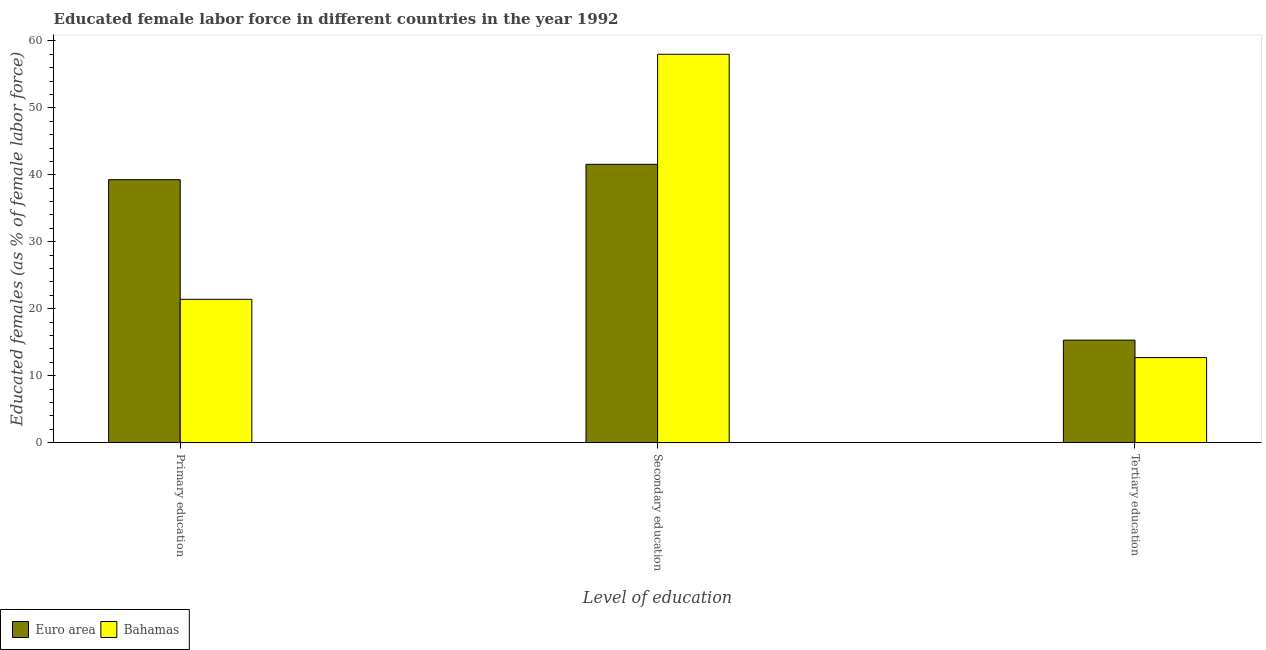How many different coloured bars are there?
Give a very brief answer. 2. Are the number of bars per tick equal to the number of legend labels?
Give a very brief answer. Yes. What is the percentage of female labor force who received primary education in Euro area?
Offer a very short reply. 39.27. Across all countries, what is the maximum percentage of female labor force who received secondary education?
Your response must be concise. 58. Across all countries, what is the minimum percentage of female labor force who received tertiary education?
Make the answer very short. 12.7. In which country was the percentage of female labor force who received secondary education maximum?
Provide a short and direct response. Bahamas. What is the total percentage of female labor force who received primary education in the graph?
Provide a succinct answer. 60.67. What is the difference between the percentage of female labor force who received primary education in Bahamas and that in Euro area?
Offer a very short reply. -17.87. What is the difference between the percentage of female labor force who received primary education in Bahamas and the percentage of female labor force who received tertiary education in Euro area?
Your response must be concise. 6.09. What is the average percentage of female labor force who received secondary education per country?
Ensure brevity in your answer.  49.78. What is the difference between the percentage of female labor force who received tertiary education and percentage of female labor force who received primary education in Euro area?
Your answer should be compact. -23.96. In how many countries, is the percentage of female labor force who received secondary education greater than 24 %?
Make the answer very short. 2. What is the ratio of the percentage of female labor force who received primary education in Bahamas to that in Euro area?
Make the answer very short. 0.54. Is the percentage of female labor force who received secondary education in Euro area less than that in Bahamas?
Ensure brevity in your answer.  Yes. Is the difference between the percentage of female labor force who received tertiary education in Euro area and Bahamas greater than the difference between the percentage of female labor force who received primary education in Euro area and Bahamas?
Your answer should be compact. No. What is the difference between the highest and the second highest percentage of female labor force who received tertiary education?
Keep it short and to the point. 2.61. What is the difference between the highest and the lowest percentage of female labor force who received secondary education?
Provide a short and direct response. 16.44. Is the sum of the percentage of female labor force who received primary education in Euro area and Bahamas greater than the maximum percentage of female labor force who received tertiary education across all countries?
Ensure brevity in your answer.  Yes. What does the 1st bar from the right in Primary education represents?
Give a very brief answer. Bahamas. How many bars are there?
Offer a terse response. 6. Are all the bars in the graph horizontal?
Keep it short and to the point. No. How many countries are there in the graph?
Your answer should be compact. 2. What is the difference between two consecutive major ticks on the Y-axis?
Give a very brief answer. 10. Are the values on the major ticks of Y-axis written in scientific E-notation?
Make the answer very short. No. Where does the legend appear in the graph?
Keep it short and to the point. Bottom left. How many legend labels are there?
Your response must be concise. 2. How are the legend labels stacked?
Give a very brief answer. Horizontal. What is the title of the graph?
Ensure brevity in your answer.  Educated female labor force in different countries in the year 1992. What is the label or title of the X-axis?
Provide a succinct answer. Level of education. What is the label or title of the Y-axis?
Ensure brevity in your answer.  Educated females (as % of female labor force). What is the Educated females (as % of female labor force) of Euro area in Primary education?
Make the answer very short. 39.27. What is the Educated females (as % of female labor force) in Bahamas in Primary education?
Provide a succinct answer. 21.4. What is the Educated females (as % of female labor force) in Euro area in Secondary education?
Provide a short and direct response. 41.56. What is the Educated females (as % of female labor force) of Euro area in Tertiary education?
Your answer should be compact. 15.31. What is the Educated females (as % of female labor force) in Bahamas in Tertiary education?
Provide a short and direct response. 12.7. Across all Level of education, what is the maximum Educated females (as % of female labor force) of Euro area?
Give a very brief answer. 41.56. Across all Level of education, what is the minimum Educated females (as % of female labor force) in Euro area?
Provide a short and direct response. 15.31. Across all Level of education, what is the minimum Educated females (as % of female labor force) in Bahamas?
Give a very brief answer. 12.7. What is the total Educated females (as % of female labor force) of Euro area in the graph?
Your answer should be compact. 96.14. What is the total Educated females (as % of female labor force) of Bahamas in the graph?
Provide a short and direct response. 92.1. What is the difference between the Educated females (as % of female labor force) of Euro area in Primary education and that in Secondary education?
Offer a terse response. -2.3. What is the difference between the Educated females (as % of female labor force) in Bahamas in Primary education and that in Secondary education?
Ensure brevity in your answer.  -36.6. What is the difference between the Educated females (as % of female labor force) of Euro area in Primary education and that in Tertiary education?
Ensure brevity in your answer.  23.96. What is the difference between the Educated females (as % of female labor force) in Euro area in Secondary education and that in Tertiary education?
Provide a short and direct response. 26.26. What is the difference between the Educated females (as % of female labor force) of Bahamas in Secondary education and that in Tertiary education?
Make the answer very short. 45.3. What is the difference between the Educated females (as % of female labor force) of Euro area in Primary education and the Educated females (as % of female labor force) of Bahamas in Secondary education?
Provide a short and direct response. -18.73. What is the difference between the Educated females (as % of female labor force) of Euro area in Primary education and the Educated females (as % of female labor force) of Bahamas in Tertiary education?
Provide a short and direct response. 26.57. What is the difference between the Educated females (as % of female labor force) of Euro area in Secondary education and the Educated females (as % of female labor force) of Bahamas in Tertiary education?
Offer a terse response. 28.86. What is the average Educated females (as % of female labor force) in Euro area per Level of education?
Keep it short and to the point. 32.05. What is the average Educated females (as % of female labor force) of Bahamas per Level of education?
Give a very brief answer. 30.7. What is the difference between the Educated females (as % of female labor force) in Euro area and Educated females (as % of female labor force) in Bahamas in Primary education?
Your answer should be very brief. 17.87. What is the difference between the Educated females (as % of female labor force) in Euro area and Educated females (as % of female labor force) in Bahamas in Secondary education?
Keep it short and to the point. -16.44. What is the difference between the Educated females (as % of female labor force) in Euro area and Educated females (as % of female labor force) in Bahamas in Tertiary education?
Offer a terse response. 2.61. What is the ratio of the Educated females (as % of female labor force) in Euro area in Primary education to that in Secondary education?
Your response must be concise. 0.94. What is the ratio of the Educated females (as % of female labor force) of Bahamas in Primary education to that in Secondary education?
Provide a succinct answer. 0.37. What is the ratio of the Educated females (as % of female labor force) in Euro area in Primary education to that in Tertiary education?
Provide a short and direct response. 2.57. What is the ratio of the Educated females (as % of female labor force) of Bahamas in Primary education to that in Tertiary education?
Offer a very short reply. 1.69. What is the ratio of the Educated females (as % of female labor force) in Euro area in Secondary education to that in Tertiary education?
Give a very brief answer. 2.72. What is the ratio of the Educated females (as % of female labor force) in Bahamas in Secondary education to that in Tertiary education?
Provide a succinct answer. 4.57. What is the difference between the highest and the second highest Educated females (as % of female labor force) of Euro area?
Give a very brief answer. 2.3. What is the difference between the highest and the second highest Educated females (as % of female labor force) in Bahamas?
Your answer should be very brief. 36.6. What is the difference between the highest and the lowest Educated females (as % of female labor force) in Euro area?
Your response must be concise. 26.26. What is the difference between the highest and the lowest Educated females (as % of female labor force) in Bahamas?
Offer a very short reply. 45.3. 